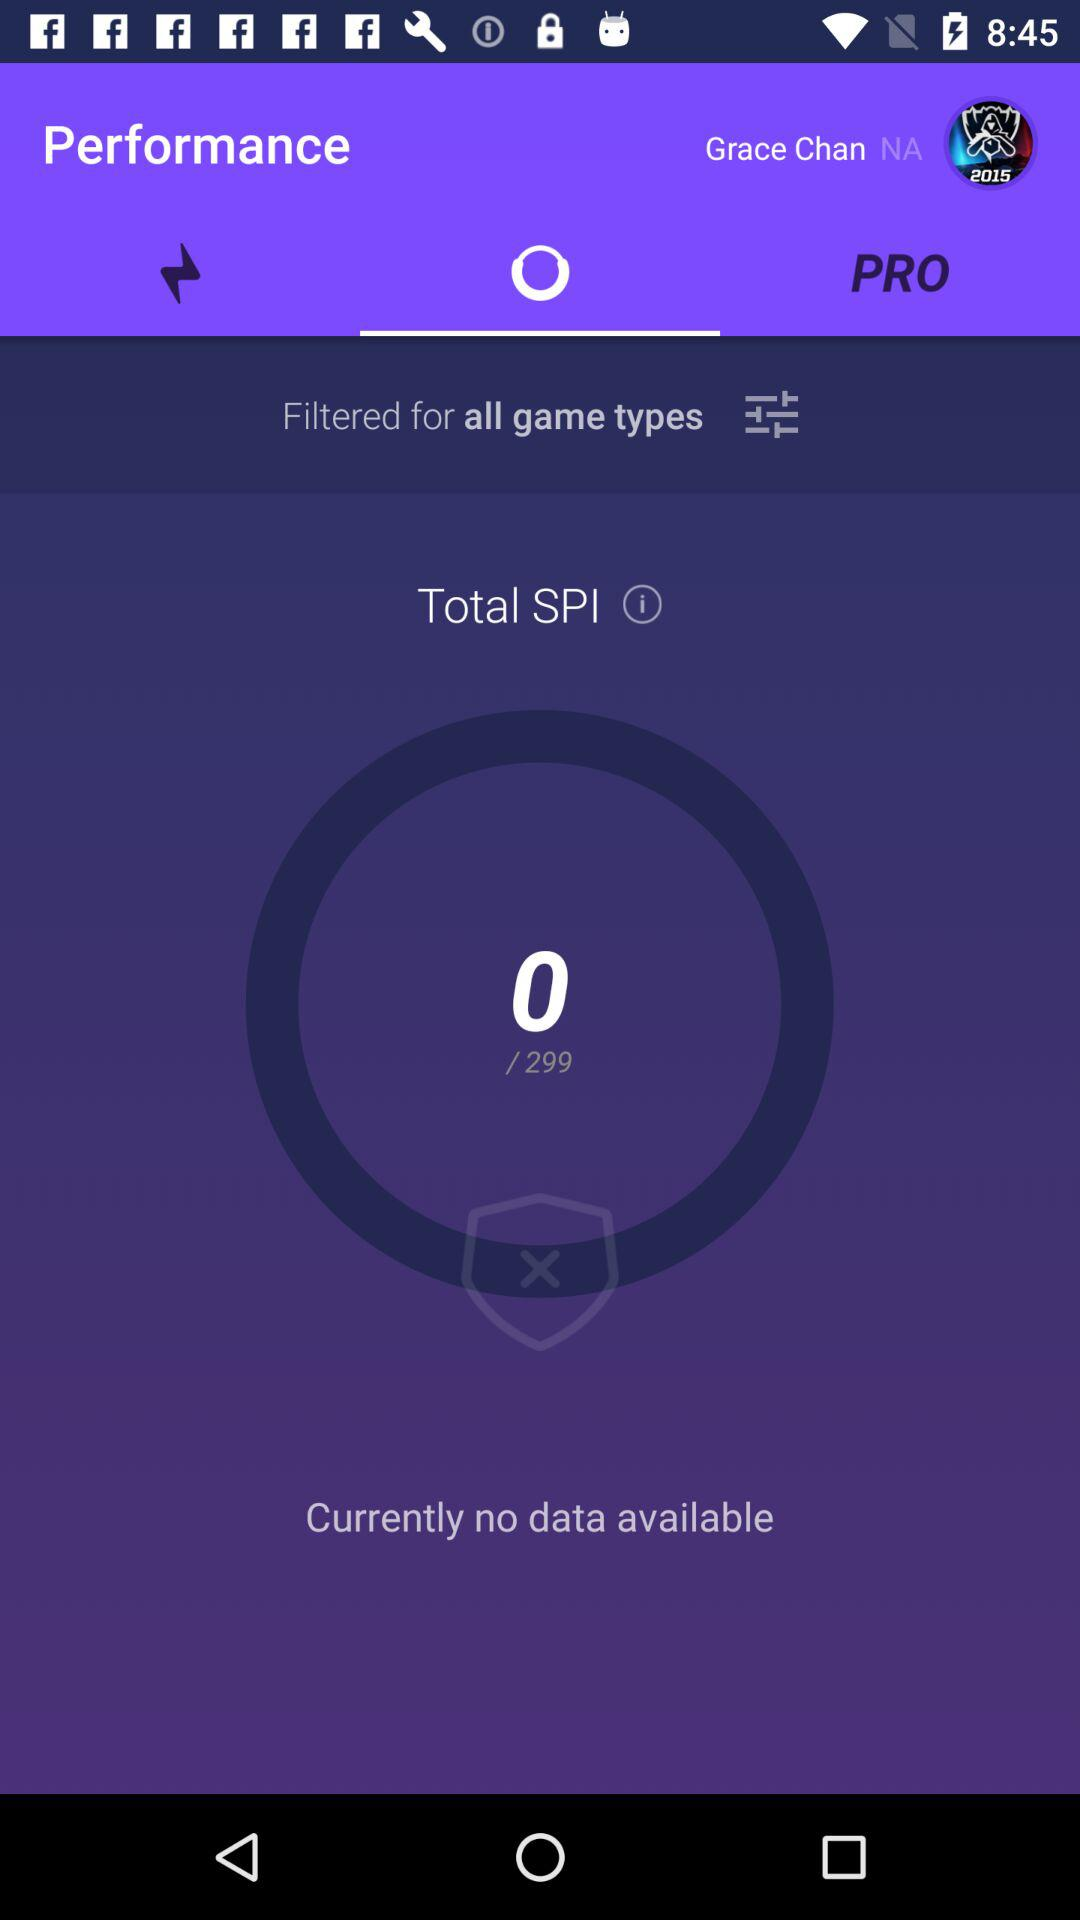What is the user name? The user name is Grace Chan. 